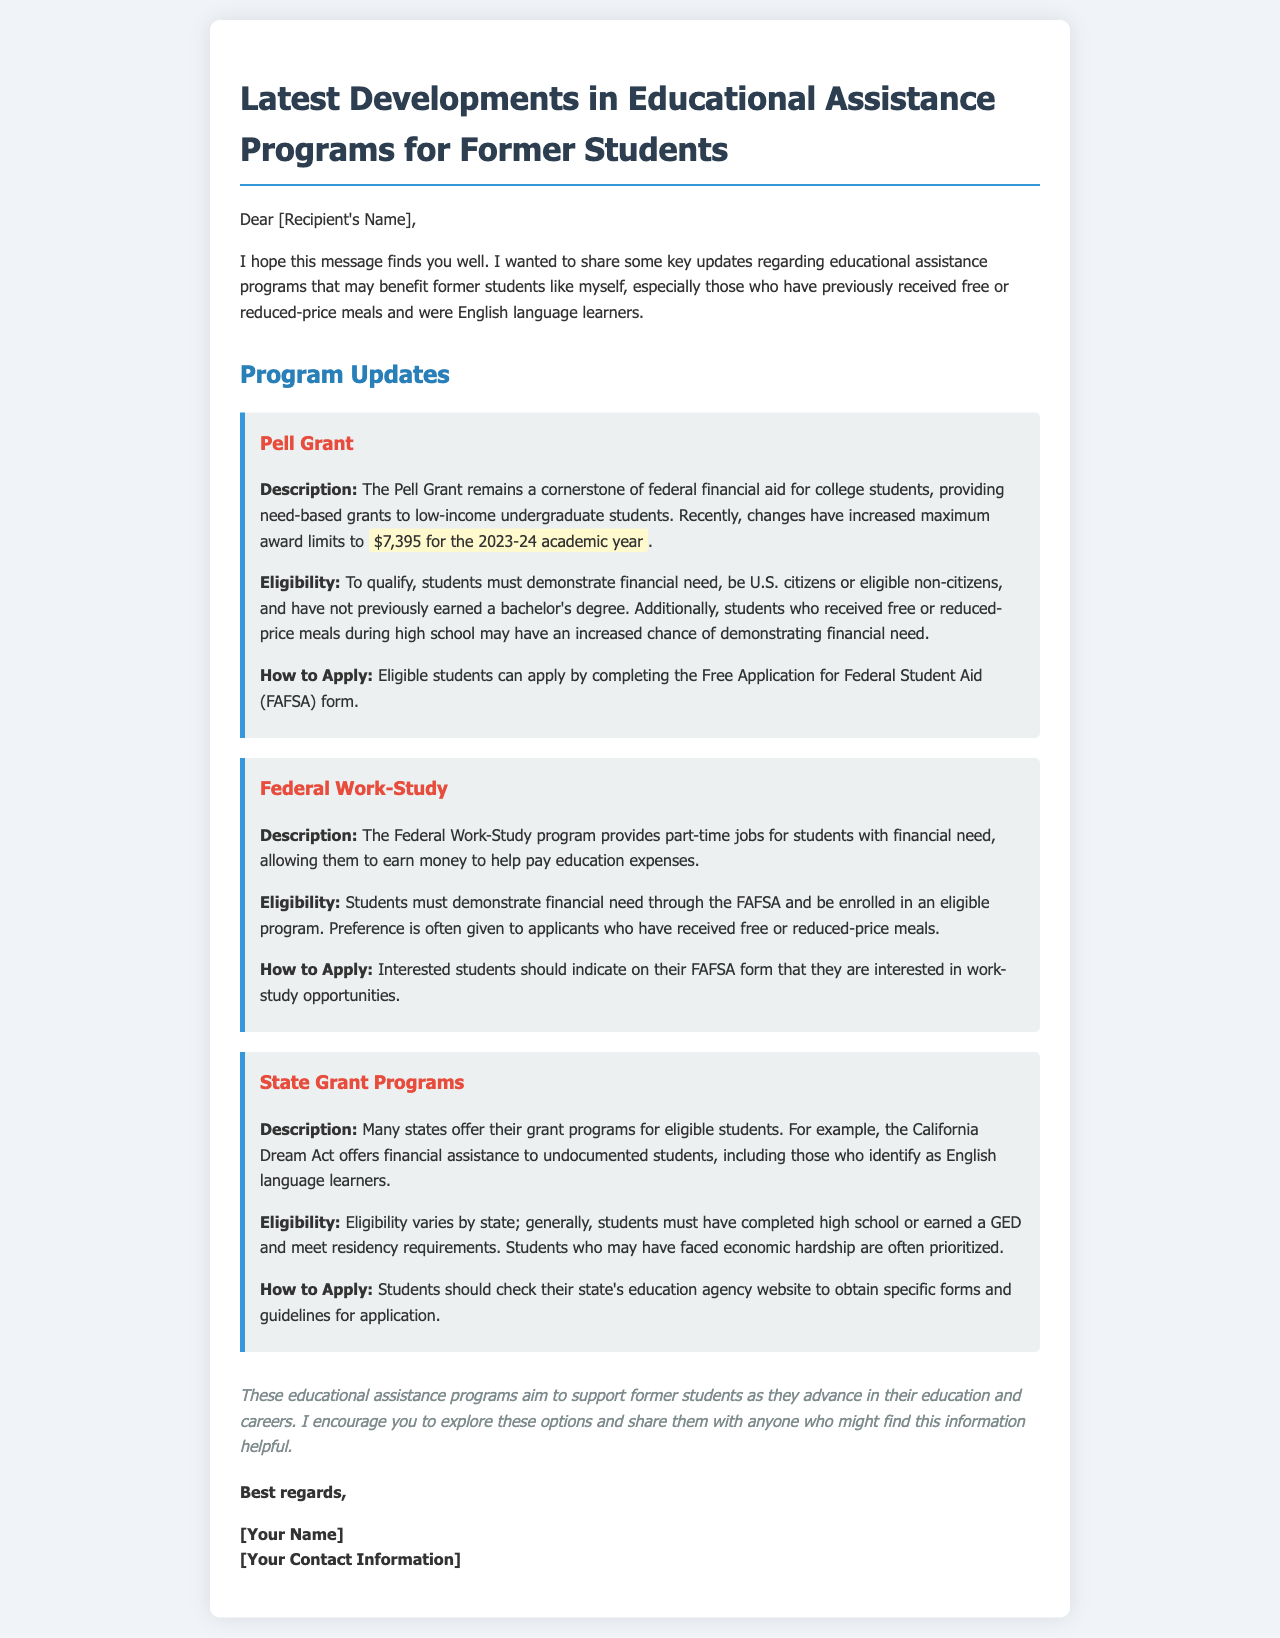What is the maximum award limit for the Pell Grant in the 2023-24 academic year? The document states that the maximum award limit for the Pell Grant has been increased to $7,395 for the 2023-24 academic year.
Answer: $7,395 What is required to qualify for the Federal Work-Study program? The document indicates that students must demonstrate financial need through the FAFSA and be enrolled in an eligible program to qualify for the Federal Work-Study program.
Answer: Financial need and enrolled in an eligible program Which act offers financial assistance to undocumented students in California? The document mentions the California Dream Act as the program that provides financial assistance to undocumented students in California.
Answer: California Dream Act What form must eligible students complete to apply for Pell Grant? The document specifies that eligible students can apply by completing the Free Application for Federal Student Aid (FAFSA) form.
Answer: FAFSA Who is prioritized in state grant programs eligibility? According to the document, students who may have faced economic hardship are often prioritized in state grant programs eligibility.
Answer: Students facing economic hardship What type of email is this document presenting? The structure and content of the document indicate that it is an email providing updates on educational assistance programs.
Answer: An email What does the conclusion encourage recipients to do? The conclusion suggests that recipients explore educational assistance options and share the information with others who might find it helpful.
Answer: Explore options and share information 